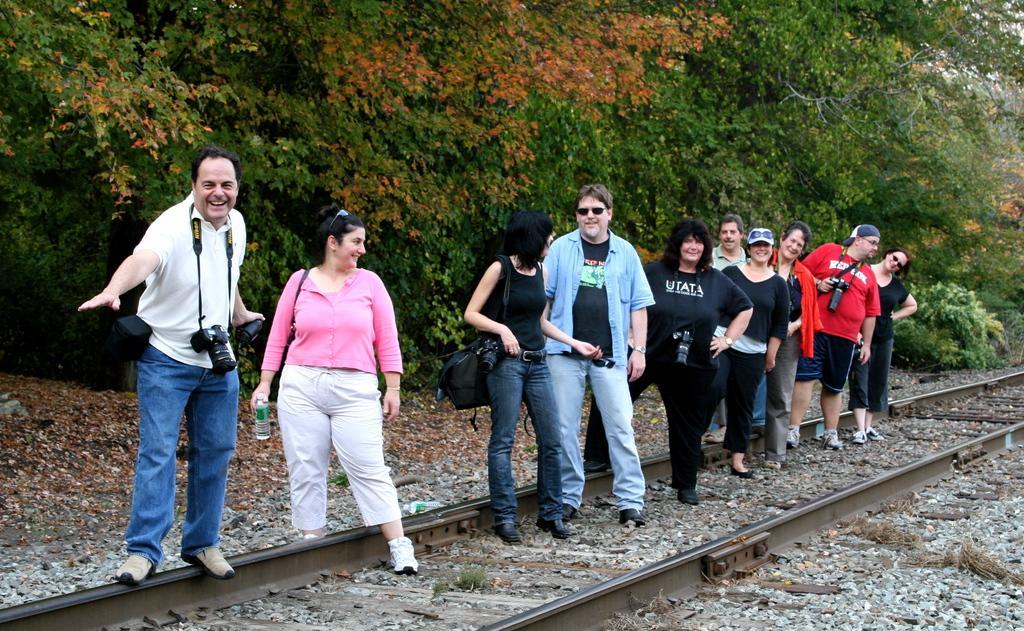Can you describe this image briefly? In the center of the image we can see people standing. At the bottom there is a railway track and we can see stones. In the background there are trees. 